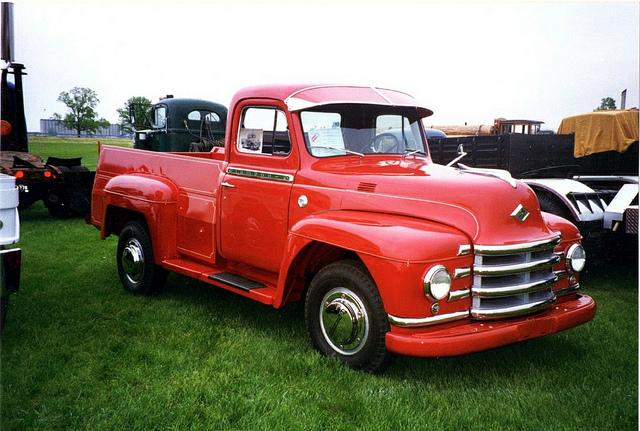What is this red truck for?

Choices:
A) refurbishment
B) rent
C) sale
D) repair sale 